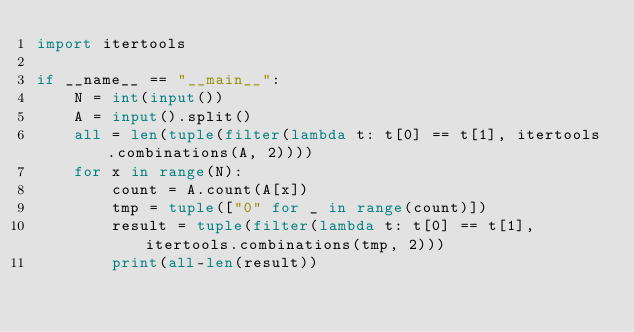<code> <loc_0><loc_0><loc_500><loc_500><_Python_>import itertools

if __name__ == "__main__":
    N = int(input())
    A = input().split()
    all = len(tuple(filter(lambda t: t[0] == t[1], itertools.combinations(A, 2))))
    for x in range(N):
        count = A.count(A[x])
        tmp = tuple(["0" for _ in range(count)])
        result = tuple(filter(lambda t: t[0] == t[1], itertools.combinations(tmp, 2)))
        print(all-len(result))
</code> 